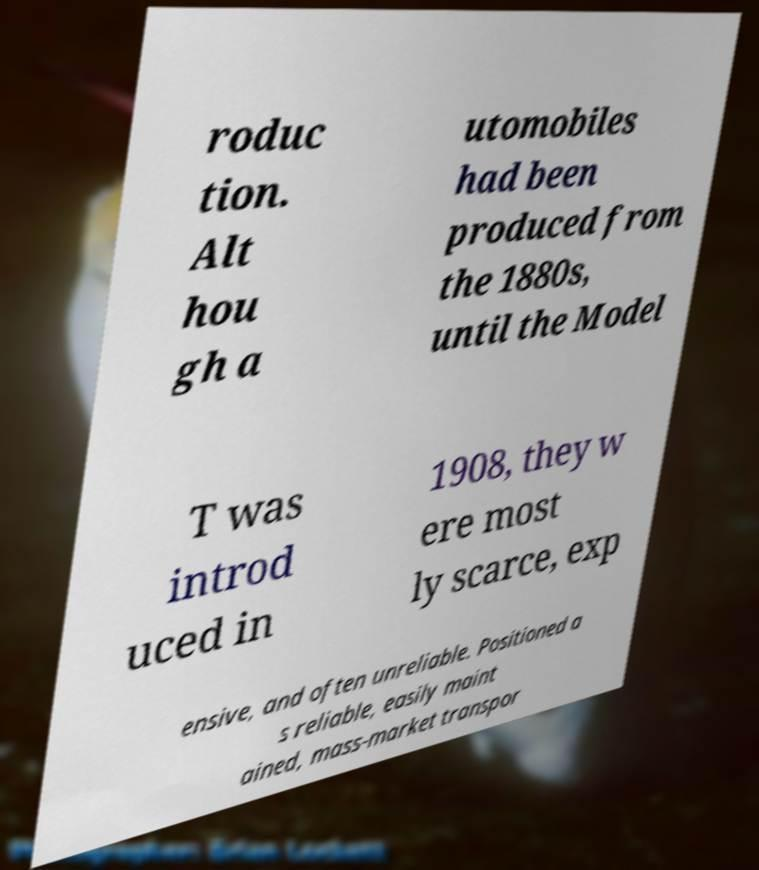I need the written content from this picture converted into text. Can you do that? roduc tion. Alt hou gh a utomobiles had been produced from the 1880s, until the Model T was introd uced in 1908, they w ere most ly scarce, exp ensive, and often unreliable. Positioned a s reliable, easily maint ained, mass-market transpor 